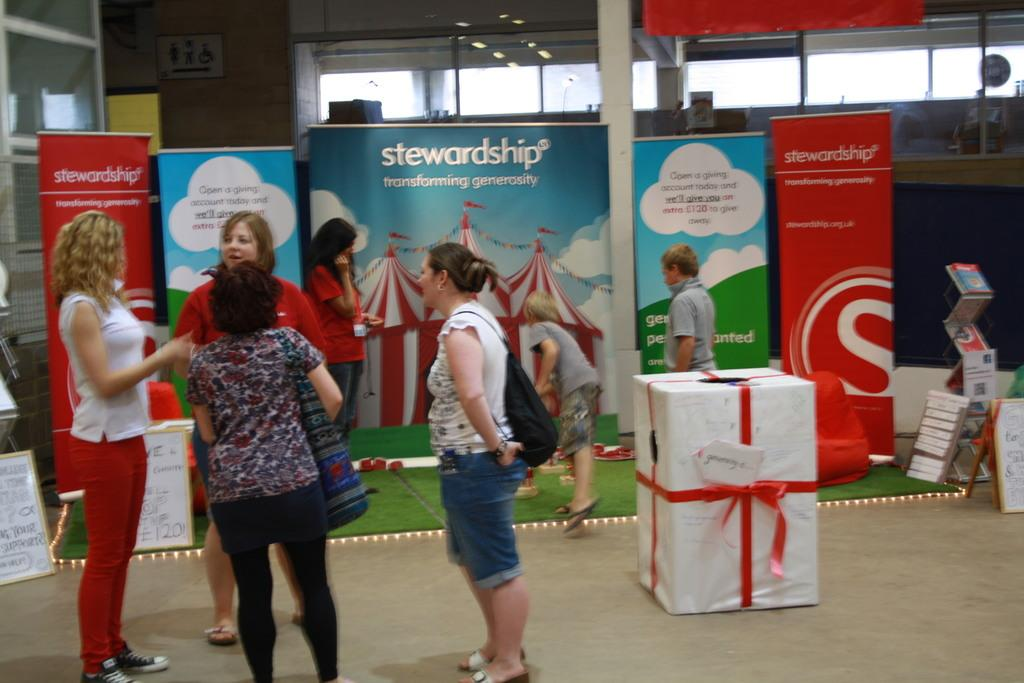<image>
Provide a brief description of the given image. A group of women speak with each other in front of a stewardship display. 